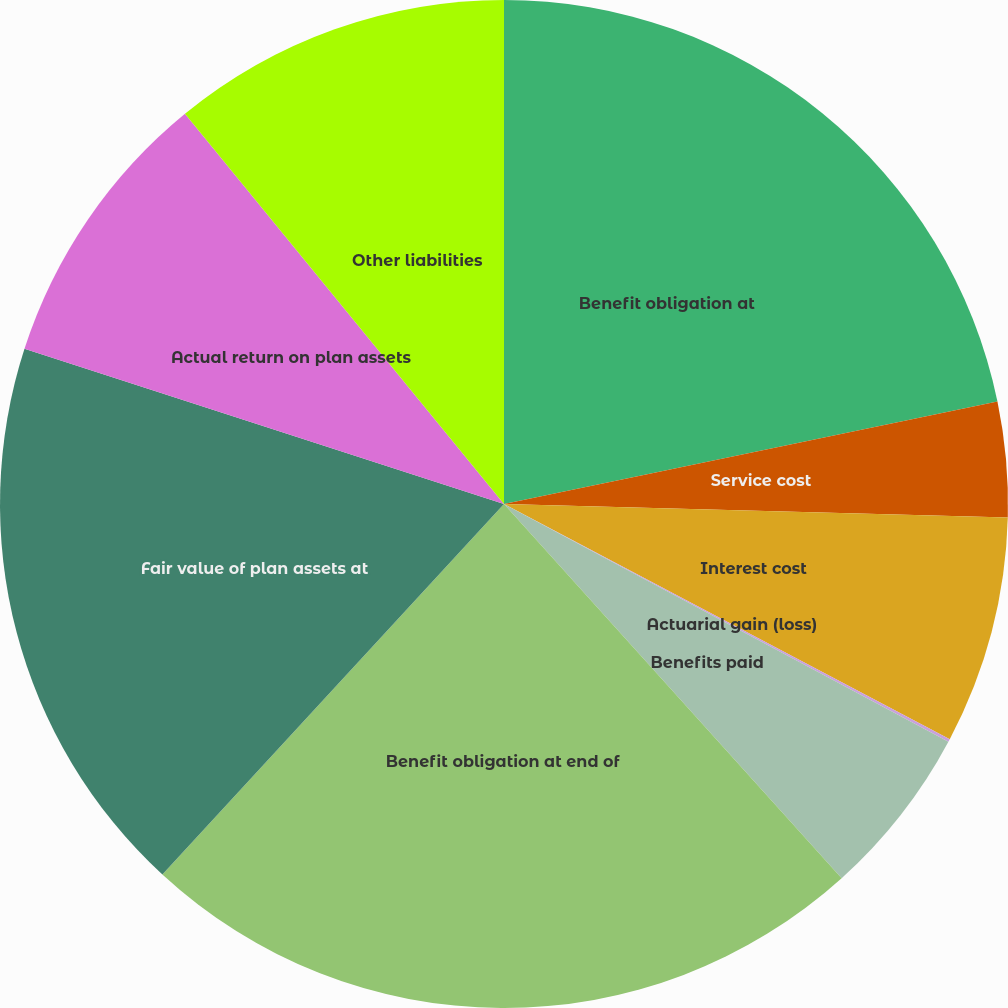Convert chart to OTSL. <chart><loc_0><loc_0><loc_500><loc_500><pie_chart><fcel>Benefit obligation at<fcel>Service cost<fcel>Interest cost<fcel>Actuarial gain (loss)<fcel>Benefits paid<fcel>Benefit obligation at end of<fcel>Fair value of plan assets at<fcel>Actual return on plan assets<fcel>Other liabilities<nl><fcel>21.74%<fcel>3.69%<fcel>7.3%<fcel>0.09%<fcel>5.5%<fcel>23.54%<fcel>18.13%<fcel>9.11%<fcel>10.91%<nl></chart> 